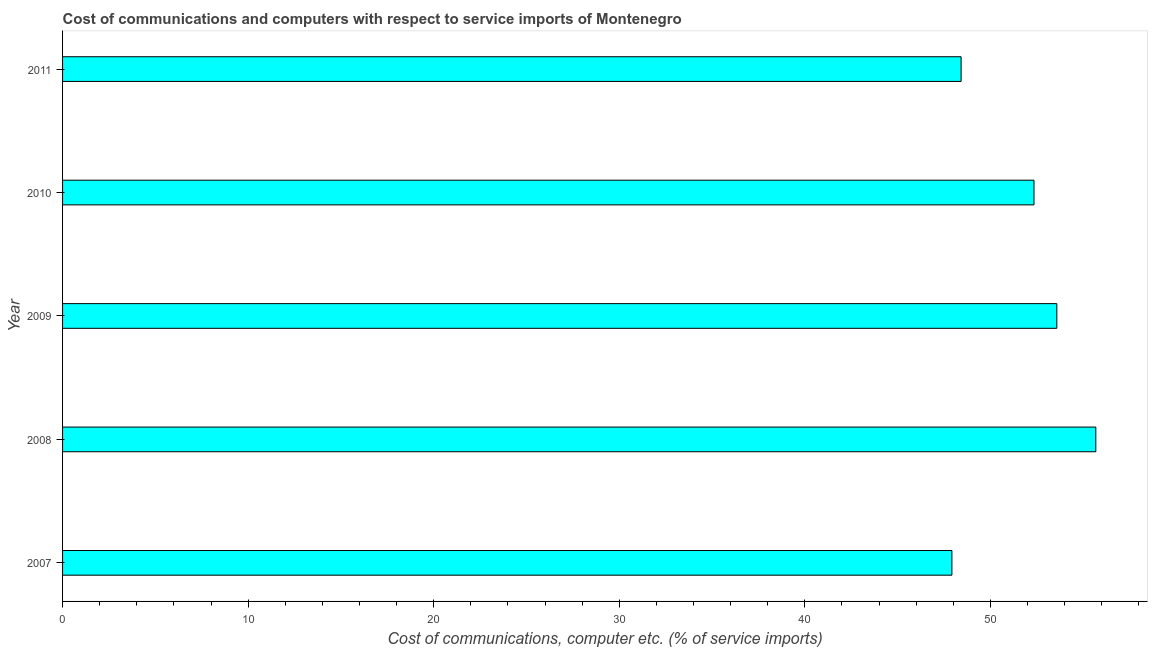Does the graph contain any zero values?
Provide a short and direct response. No. Does the graph contain grids?
Give a very brief answer. No. What is the title of the graph?
Provide a short and direct response. Cost of communications and computers with respect to service imports of Montenegro. What is the label or title of the X-axis?
Offer a very short reply. Cost of communications, computer etc. (% of service imports). What is the label or title of the Y-axis?
Make the answer very short. Year. What is the cost of communications and computer in 2008?
Offer a terse response. 55.68. Across all years, what is the maximum cost of communications and computer?
Your answer should be compact. 55.68. Across all years, what is the minimum cost of communications and computer?
Your answer should be compact. 47.93. In which year was the cost of communications and computer maximum?
Your answer should be compact. 2008. In which year was the cost of communications and computer minimum?
Offer a terse response. 2007. What is the sum of the cost of communications and computer?
Keep it short and to the point. 257.97. What is the difference between the cost of communications and computer in 2010 and 2011?
Offer a terse response. 3.93. What is the average cost of communications and computer per year?
Keep it short and to the point. 51.59. What is the median cost of communications and computer?
Provide a succinct answer. 52.35. Do a majority of the years between 2011 and 2007 (inclusive) have cost of communications and computer greater than 12 %?
Ensure brevity in your answer.  Yes. Is the cost of communications and computer in 2007 less than that in 2008?
Provide a short and direct response. Yes. Is the difference between the cost of communications and computer in 2007 and 2011 greater than the difference between any two years?
Make the answer very short. No. What is the difference between the highest and the second highest cost of communications and computer?
Your response must be concise. 2.1. What is the difference between the highest and the lowest cost of communications and computer?
Give a very brief answer. 7.76. In how many years, is the cost of communications and computer greater than the average cost of communications and computer taken over all years?
Ensure brevity in your answer.  3. Are all the bars in the graph horizontal?
Your answer should be very brief. Yes. How many years are there in the graph?
Give a very brief answer. 5. What is the difference between two consecutive major ticks on the X-axis?
Give a very brief answer. 10. What is the Cost of communications, computer etc. (% of service imports) of 2007?
Your response must be concise. 47.93. What is the Cost of communications, computer etc. (% of service imports) of 2008?
Provide a succinct answer. 55.68. What is the Cost of communications, computer etc. (% of service imports) in 2009?
Provide a succinct answer. 53.58. What is the Cost of communications, computer etc. (% of service imports) of 2010?
Your answer should be very brief. 52.35. What is the Cost of communications, computer etc. (% of service imports) of 2011?
Provide a short and direct response. 48.42. What is the difference between the Cost of communications, computer etc. (% of service imports) in 2007 and 2008?
Your answer should be compact. -7.76. What is the difference between the Cost of communications, computer etc. (% of service imports) in 2007 and 2009?
Keep it short and to the point. -5.65. What is the difference between the Cost of communications, computer etc. (% of service imports) in 2007 and 2010?
Your response must be concise. -4.42. What is the difference between the Cost of communications, computer etc. (% of service imports) in 2007 and 2011?
Provide a succinct answer. -0.5. What is the difference between the Cost of communications, computer etc. (% of service imports) in 2008 and 2009?
Make the answer very short. 2.1. What is the difference between the Cost of communications, computer etc. (% of service imports) in 2008 and 2010?
Provide a succinct answer. 3.33. What is the difference between the Cost of communications, computer etc. (% of service imports) in 2008 and 2011?
Make the answer very short. 7.26. What is the difference between the Cost of communications, computer etc. (% of service imports) in 2009 and 2010?
Your response must be concise. 1.23. What is the difference between the Cost of communications, computer etc. (% of service imports) in 2009 and 2011?
Make the answer very short. 5.16. What is the difference between the Cost of communications, computer etc. (% of service imports) in 2010 and 2011?
Give a very brief answer. 3.93. What is the ratio of the Cost of communications, computer etc. (% of service imports) in 2007 to that in 2008?
Your response must be concise. 0.86. What is the ratio of the Cost of communications, computer etc. (% of service imports) in 2007 to that in 2009?
Provide a succinct answer. 0.89. What is the ratio of the Cost of communications, computer etc. (% of service imports) in 2007 to that in 2010?
Your answer should be compact. 0.92. What is the ratio of the Cost of communications, computer etc. (% of service imports) in 2008 to that in 2009?
Offer a very short reply. 1.04. What is the ratio of the Cost of communications, computer etc. (% of service imports) in 2008 to that in 2010?
Your response must be concise. 1.06. What is the ratio of the Cost of communications, computer etc. (% of service imports) in 2008 to that in 2011?
Provide a short and direct response. 1.15. What is the ratio of the Cost of communications, computer etc. (% of service imports) in 2009 to that in 2010?
Offer a terse response. 1.02. What is the ratio of the Cost of communications, computer etc. (% of service imports) in 2009 to that in 2011?
Offer a very short reply. 1.11. What is the ratio of the Cost of communications, computer etc. (% of service imports) in 2010 to that in 2011?
Your answer should be compact. 1.08. 